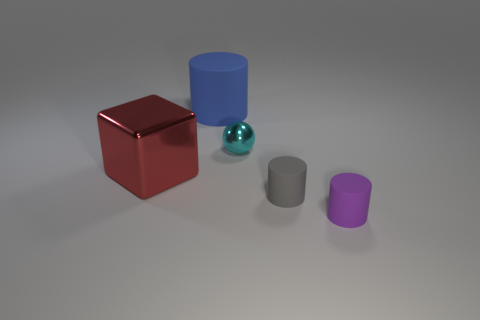Add 5 blue objects. How many objects exist? 10 Subtract all spheres. How many objects are left? 4 Subtract all tiny purple objects. Subtract all tiny gray rubber cylinders. How many objects are left? 3 Add 5 tiny cyan objects. How many tiny cyan objects are left? 6 Add 1 big matte cylinders. How many big matte cylinders exist? 2 Subtract 0 yellow blocks. How many objects are left? 5 